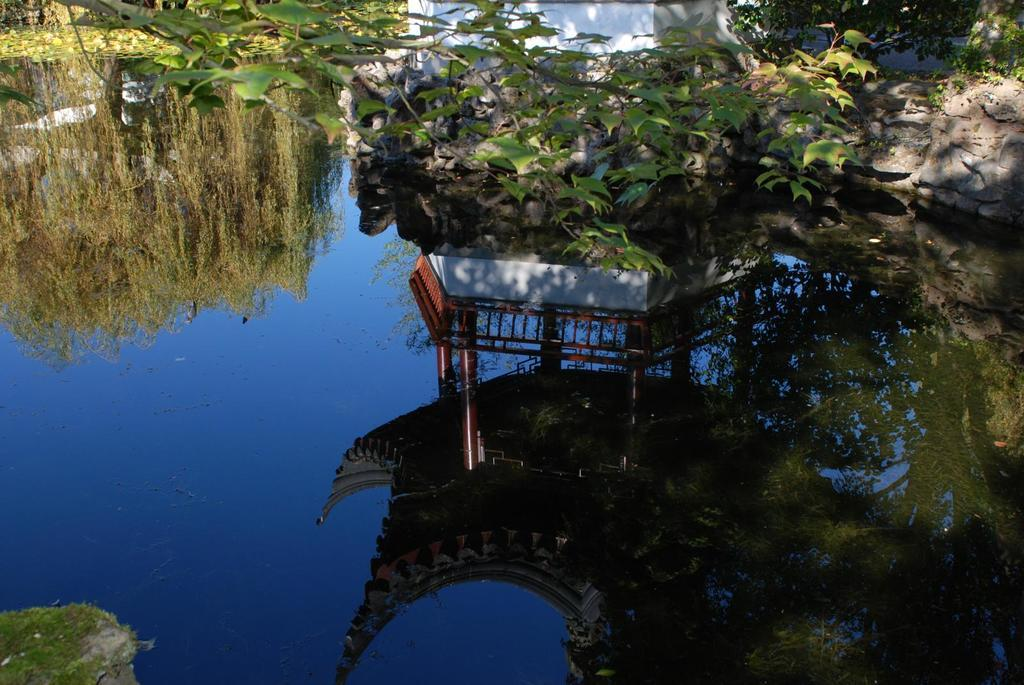What type of object is made of metal in the image? There is a metal object in the image, but the specific type cannot be determined from the facts provided. What can be seen in the water due to the metal object? The metal object's reflection is visible in the water. What type of vegetation is present in the image? There are plants in the image. What type of inanimate objects can be seen in the image besides the metal object? There are stones in the image. What type of knife is the queen using to cut the plants in the image? There is no knife or queen present in the image; it only features a metal object, plants, and stones. 